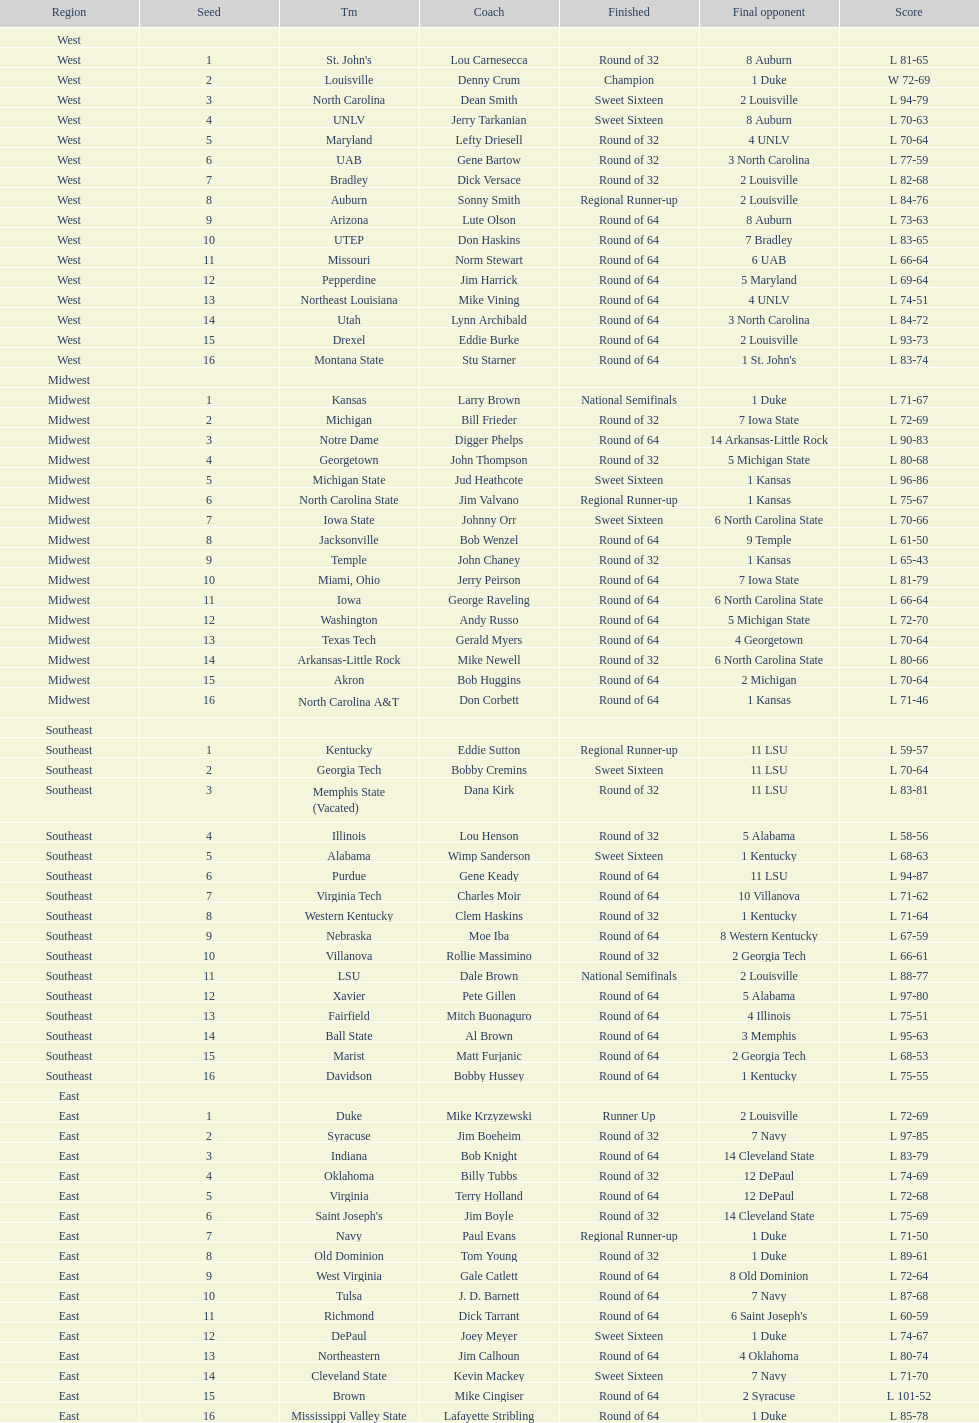Which round did north carolina and unlv each achieve? Sweet Sixteen. 